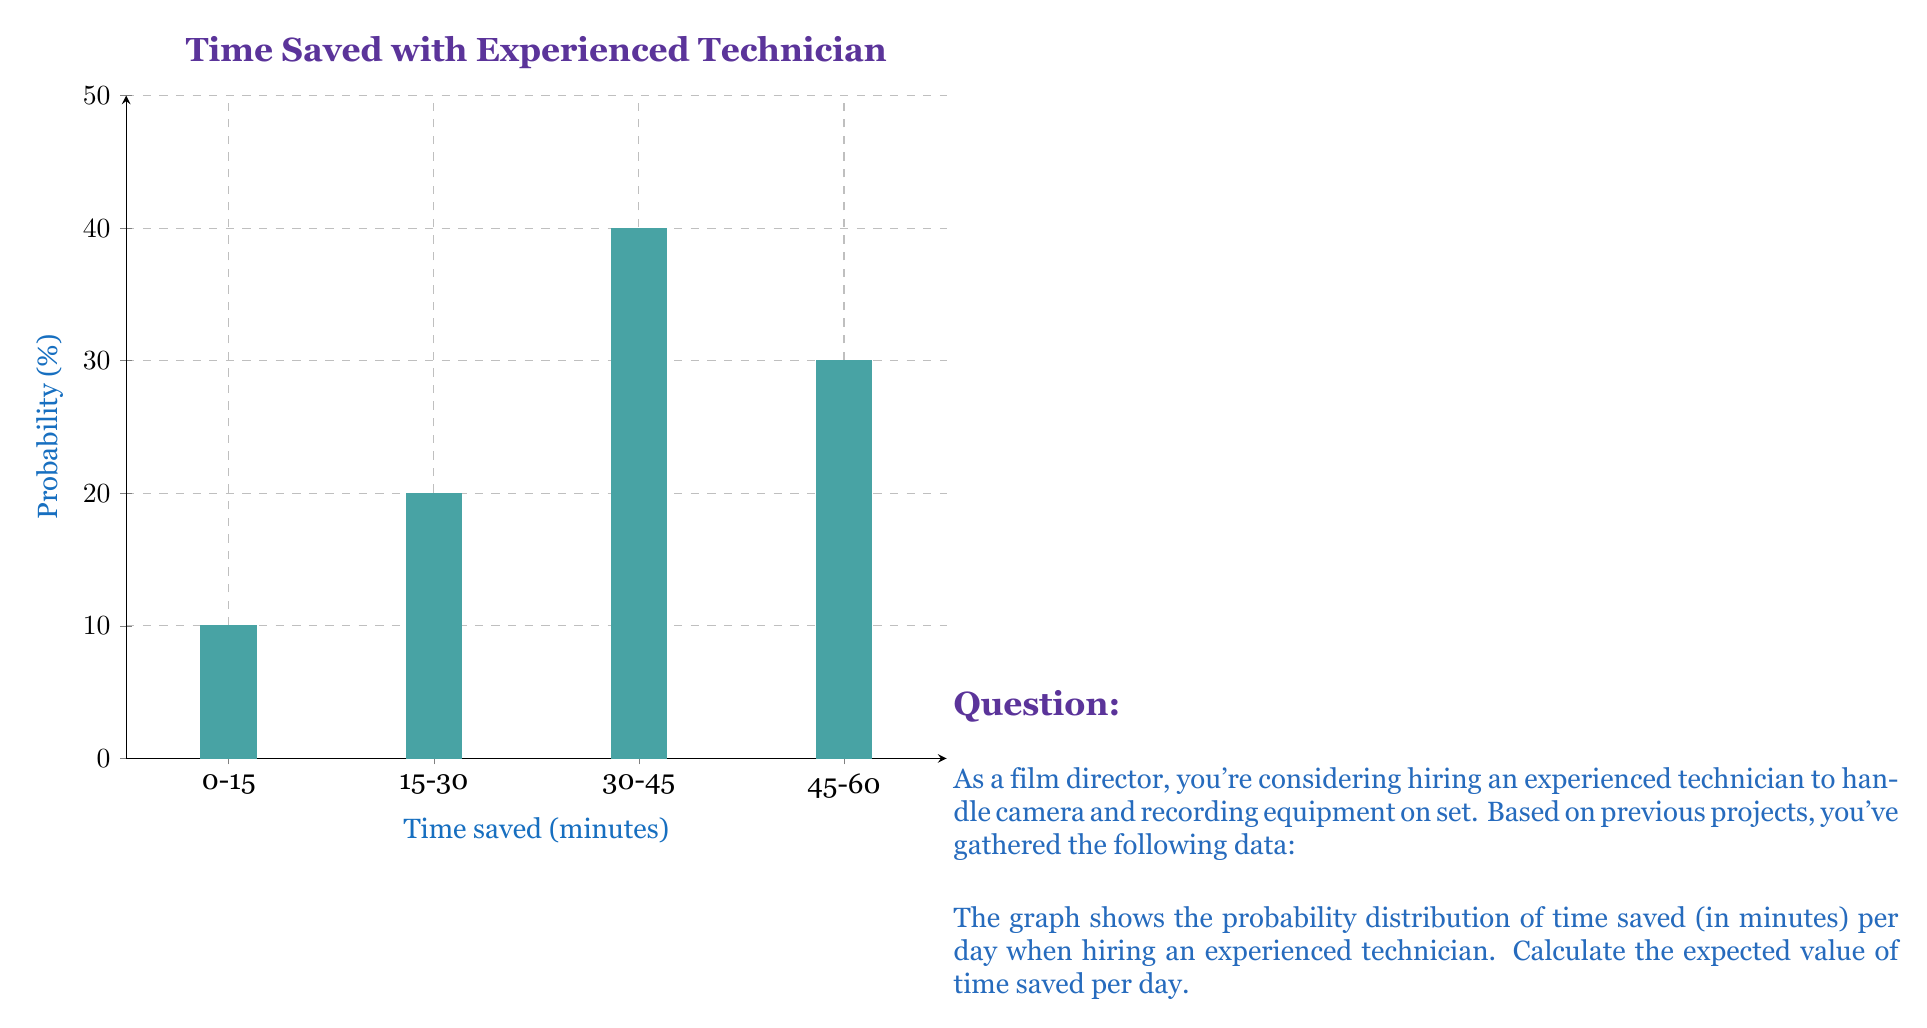Solve this math problem. To calculate the expected value, we need to:
1. Identify the midpoint of each time range
2. Multiply each midpoint by its probability
3. Sum these products

Let's go through this step-by-step:

1. Midpoints of time ranges:
   - 0-15 minutes: $(0+15)/2 = 7.5$ minutes
   - 15-30 minutes: $(15+30)/2 = 22.5$ minutes
   - 30-45 minutes: $(30+45)/2 = 37.5$ minutes
   - 45-60 minutes: $(45+60)/2 = 52.5$ minutes

2. Probabilities from the graph:
   - 0-15 minutes: 10%
   - 15-30 minutes: 20%
   - 30-45 minutes: 40%
   - 45-60 minutes: 30%

3. Multiply midpoints by probabilities:
   - $7.5 \times 0.10 = 0.75$
   - $22.5 \times 0.20 = 4.5$
   - $37.5 \times 0.40 = 15$
   - $52.5 \times 0.30 = 15.75$

4. Sum the products:

   $E(\text{time saved}) = 0.75 + 4.5 + 15 + 15.75 = 36$ minutes

Therefore, the expected value of time saved per day is 36 minutes.
Answer: 36 minutes 